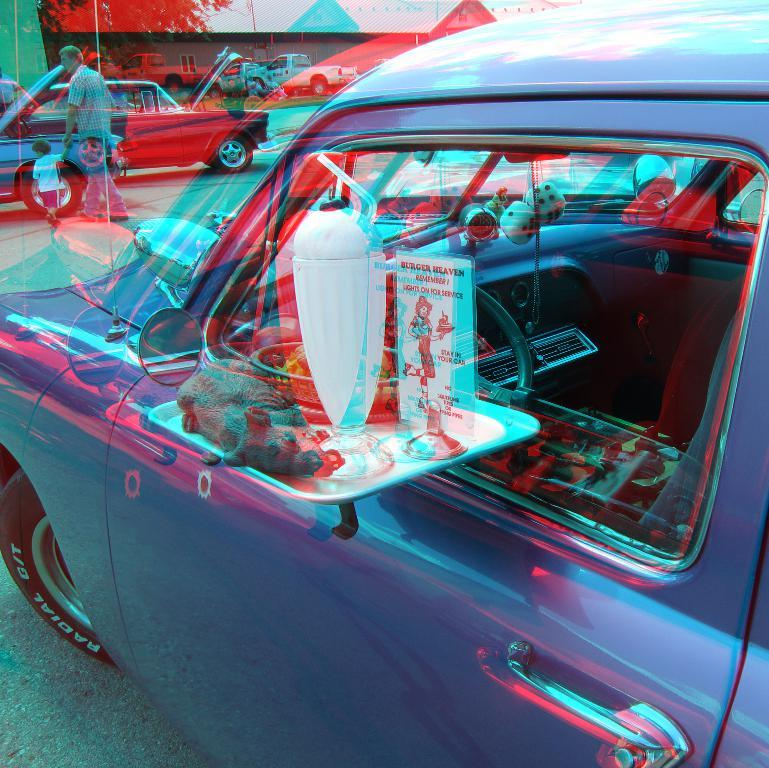What is the main subject of the image? The main subject of the image is a car. How is the car positioned in the image? The car is shown from the side. Who is present in front of the car? There is a man in front of the car, and he is accompanied by a child. What are the man and the child doing in the image? The man and the child are walking on the road. Are there any other vehicles visible in the image? Yes, there are other cars visible in the image. What type of structures can be seen in the background? There are houses in the image. Can you tell me how many times the child jumps in the image? There is no indication in the image that the child is jumping; they are walking alongside the man. 